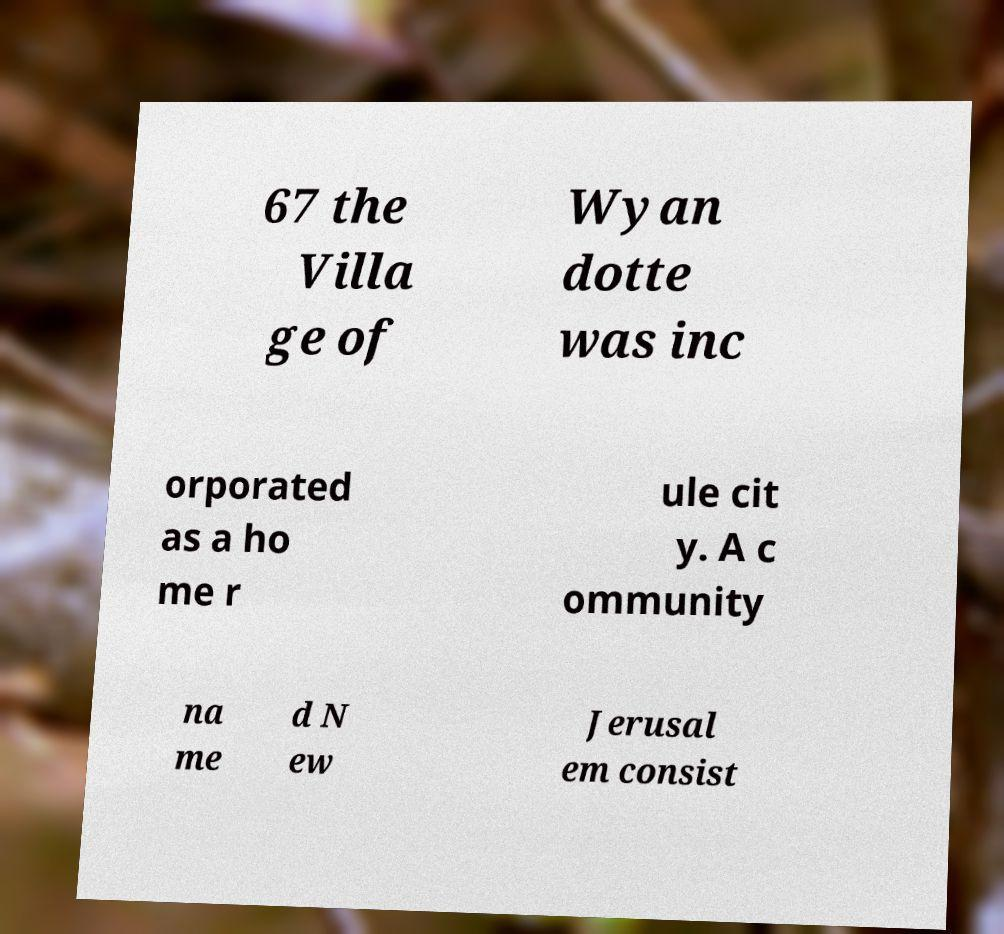Can you read and provide the text displayed in the image?This photo seems to have some interesting text. Can you extract and type it out for me? 67 the Villa ge of Wyan dotte was inc orporated as a ho me r ule cit y. A c ommunity na me d N ew Jerusal em consist 